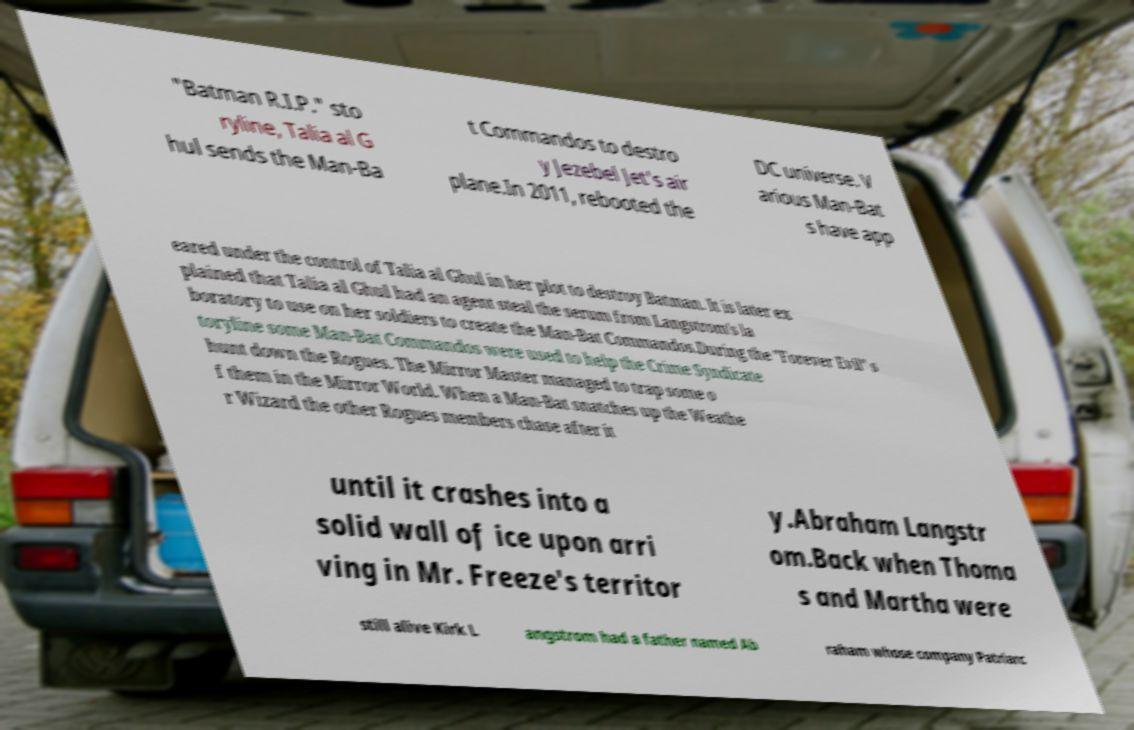What messages or text are displayed in this image? I need them in a readable, typed format. "Batman R.I.P." sto ryline, Talia al G hul sends the Man-Ba t Commandos to destro y Jezebel Jet's air plane.In 2011, rebooted the DC universe. V arious Man-Bat s have app eared under the control of Talia al Ghul in her plot to destroy Batman. It is later ex plained that Talia al Ghul had an agent steal the serum from Langstrom's la boratory to use on her soldiers to create the Man-Bat Commandos.During the "Forever Evil" s toryline some Man-Bat Commandos were used to help the Crime Syndicate hunt down the Rogues. The Mirror Master managed to trap some o f them in the Mirror World. When a Man-Bat snatches up the Weathe r Wizard the other Rogues members chase after it until it crashes into a solid wall of ice upon arri ving in Mr. Freeze's territor y.Abraham Langstr om.Back when Thoma s and Martha were still alive Kirk L angstrom had a father named Ab raham whose company Patriarc 